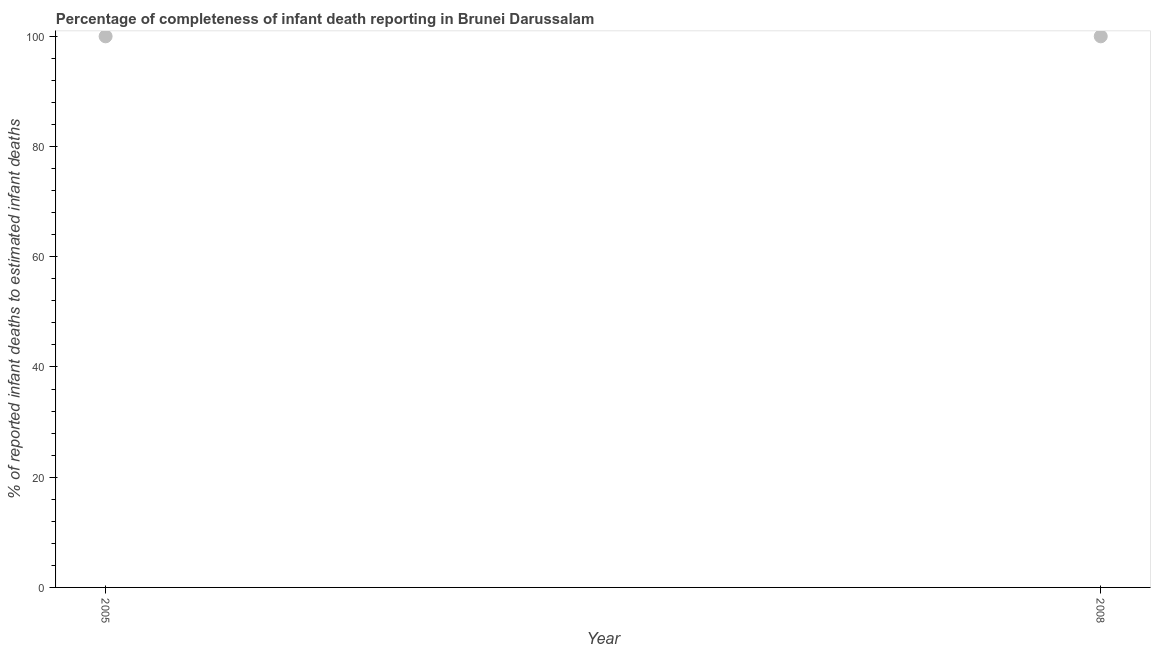What is the completeness of infant death reporting in 2008?
Make the answer very short. 100. Across all years, what is the maximum completeness of infant death reporting?
Keep it short and to the point. 100. Across all years, what is the minimum completeness of infant death reporting?
Keep it short and to the point. 100. In which year was the completeness of infant death reporting maximum?
Keep it short and to the point. 2005. In which year was the completeness of infant death reporting minimum?
Provide a succinct answer. 2005. What is the sum of the completeness of infant death reporting?
Offer a very short reply. 200. Do a majority of the years between 2005 and 2008 (inclusive) have completeness of infant death reporting greater than 96 %?
Your response must be concise. Yes. Is the completeness of infant death reporting in 2005 less than that in 2008?
Your answer should be compact. No. In how many years, is the completeness of infant death reporting greater than the average completeness of infant death reporting taken over all years?
Your answer should be very brief. 0. How many dotlines are there?
Make the answer very short. 1. How many years are there in the graph?
Make the answer very short. 2. What is the difference between two consecutive major ticks on the Y-axis?
Keep it short and to the point. 20. What is the title of the graph?
Keep it short and to the point. Percentage of completeness of infant death reporting in Brunei Darussalam. What is the label or title of the X-axis?
Make the answer very short. Year. What is the label or title of the Y-axis?
Ensure brevity in your answer.  % of reported infant deaths to estimated infant deaths. What is the % of reported infant deaths to estimated infant deaths in 2008?
Your answer should be very brief. 100. What is the difference between the % of reported infant deaths to estimated infant deaths in 2005 and 2008?
Offer a terse response. 0. What is the ratio of the % of reported infant deaths to estimated infant deaths in 2005 to that in 2008?
Your response must be concise. 1. 